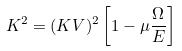Convert formula to latex. <formula><loc_0><loc_0><loc_500><loc_500>K ^ { 2 } = ( K V ) ^ { 2 } \left [ 1 - \mu \frac { \Omega } { E } \right ]</formula> 